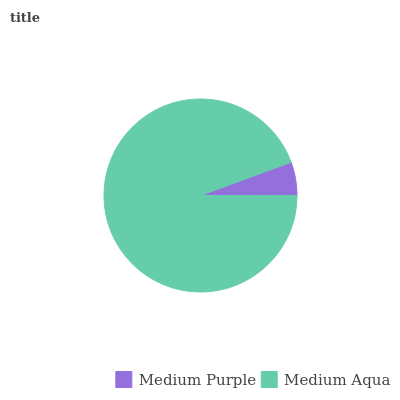Is Medium Purple the minimum?
Answer yes or no. Yes. Is Medium Aqua the maximum?
Answer yes or no. Yes. Is Medium Aqua the minimum?
Answer yes or no. No. Is Medium Aqua greater than Medium Purple?
Answer yes or no. Yes. Is Medium Purple less than Medium Aqua?
Answer yes or no. Yes. Is Medium Purple greater than Medium Aqua?
Answer yes or no. No. Is Medium Aqua less than Medium Purple?
Answer yes or no. No. Is Medium Aqua the high median?
Answer yes or no. Yes. Is Medium Purple the low median?
Answer yes or no. Yes. Is Medium Purple the high median?
Answer yes or no. No. Is Medium Aqua the low median?
Answer yes or no. No. 